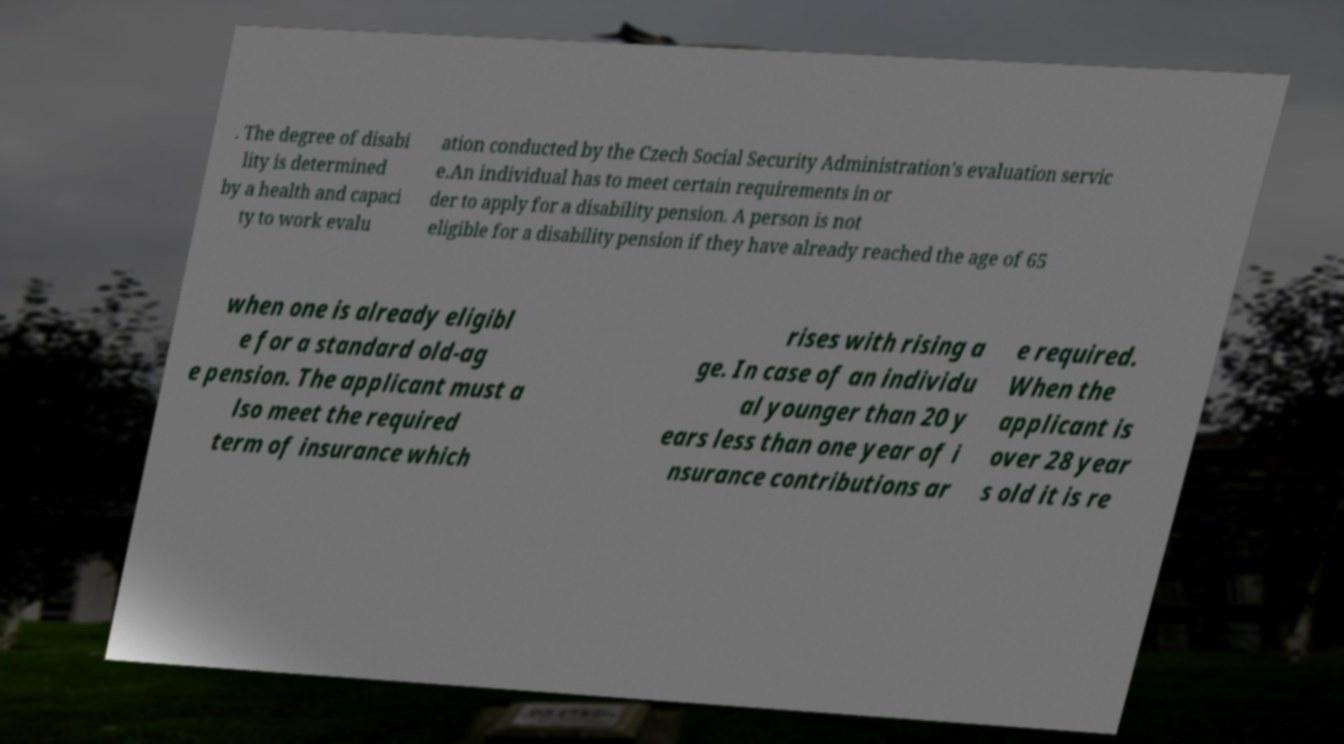There's text embedded in this image that I need extracted. Can you transcribe it verbatim? . The degree of disabi lity is determined by a health and capaci ty to work evalu ation conducted by the Czech Social Security Administration's evaluation servic e.An individual has to meet certain requirements in or der to apply for a disability pension. A person is not eligible for a disability pension if they have already reached the age of 65 when one is already eligibl e for a standard old-ag e pension. The applicant must a lso meet the required term of insurance which rises with rising a ge. In case of an individu al younger than 20 y ears less than one year of i nsurance contributions ar e required. When the applicant is over 28 year s old it is re 